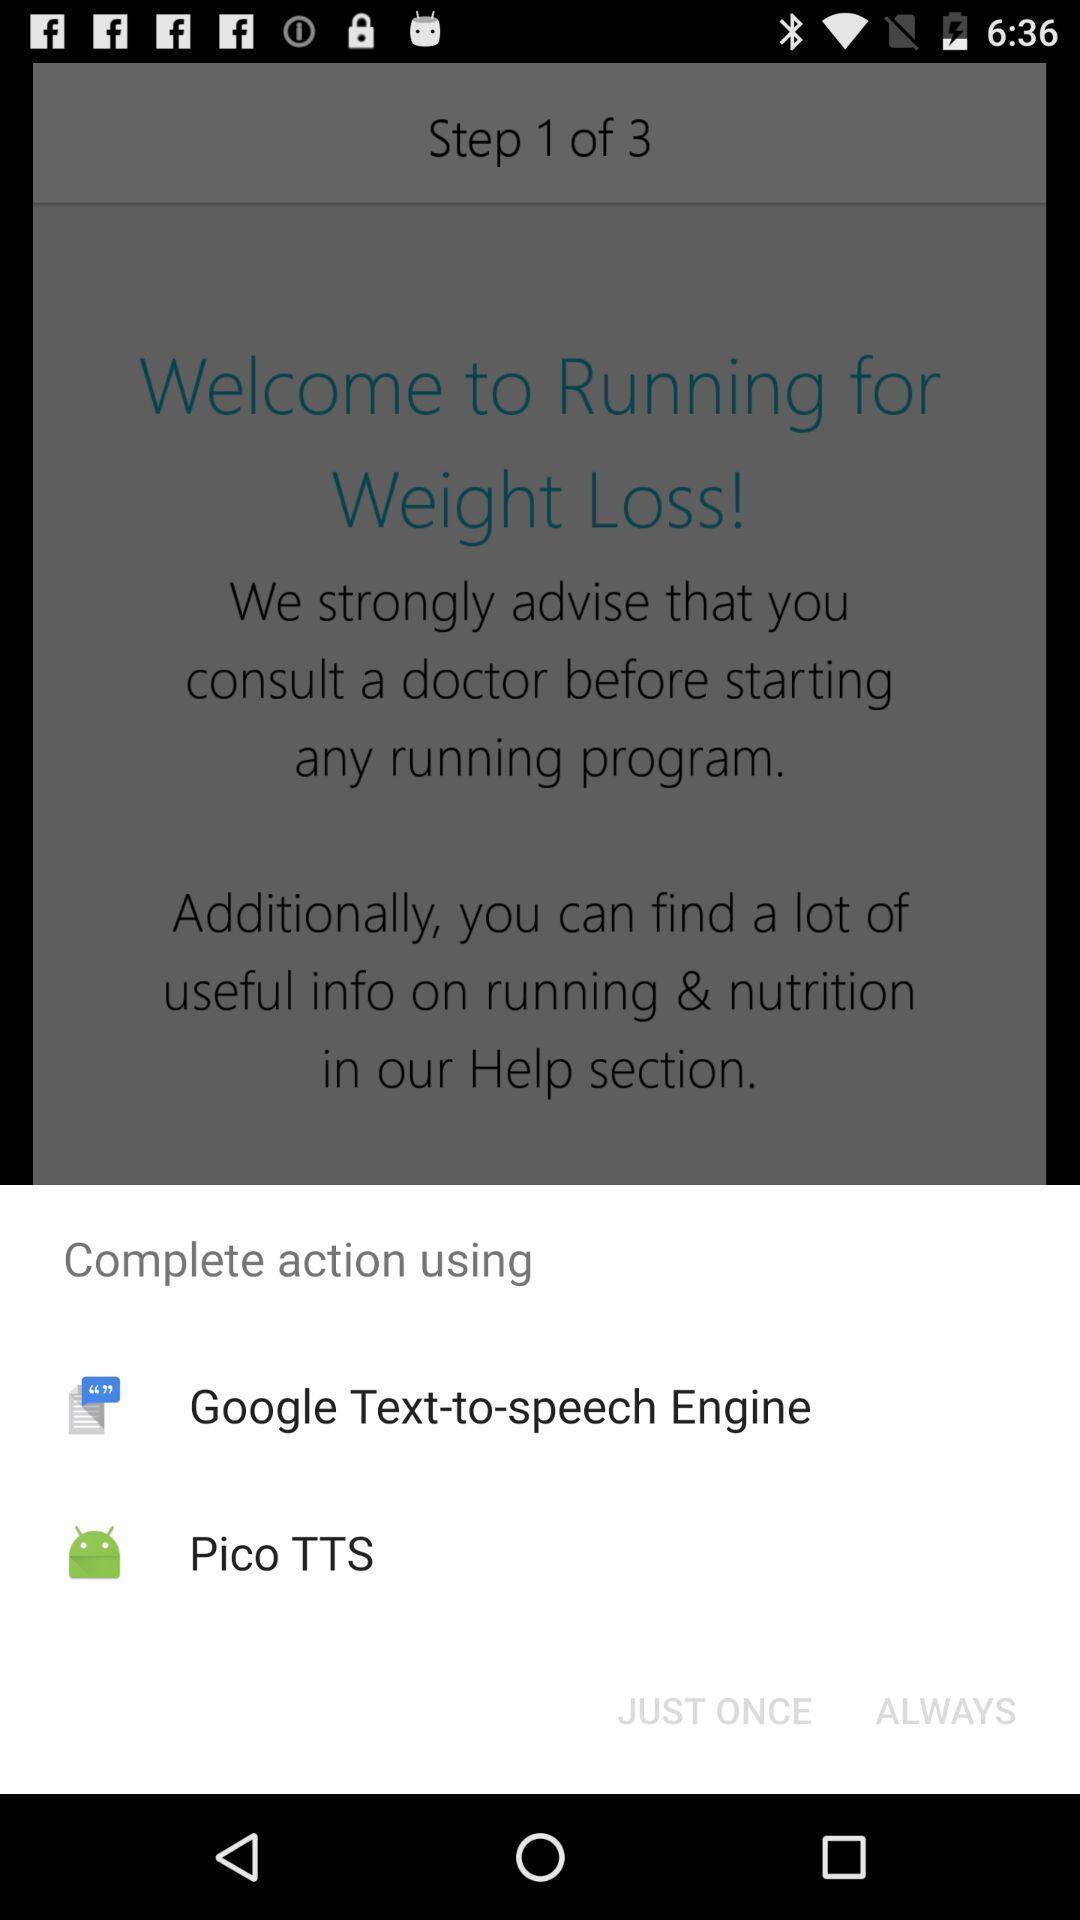Summarize the main components in this picture. Pop up to continue options. 